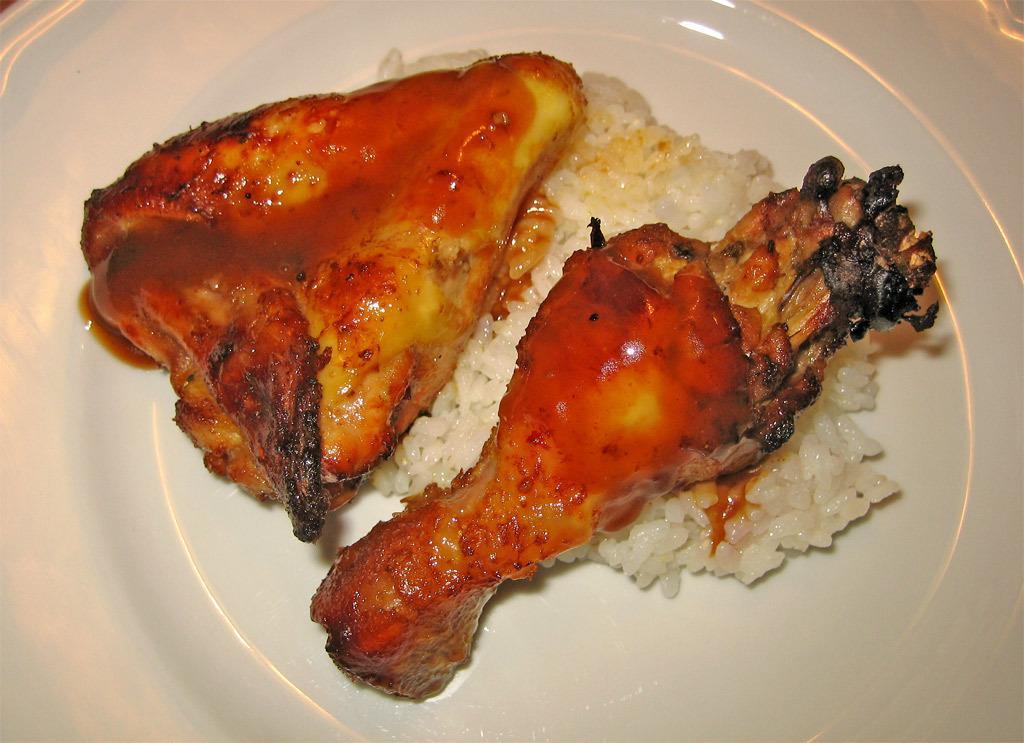Describe this image in one or two sentences. In this image in the center there is one plate, in that place there is some food and chicken. 